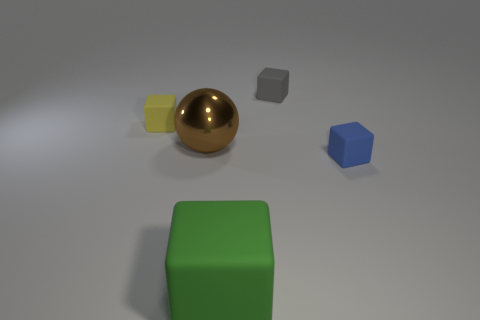Subtract 1 blocks. How many blocks are left? 3 Add 4 big red rubber cylinders. How many objects exist? 9 Subtract all blocks. How many objects are left? 1 Subtract 0 green balls. How many objects are left? 5 Subtract all big gray metallic blocks. Subtract all tiny yellow matte cubes. How many objects are left? 4 Add 5 blue matte blocks. How many blue matte blocks are left? 6 Add 3 big green things. How many big green things exist? 4 